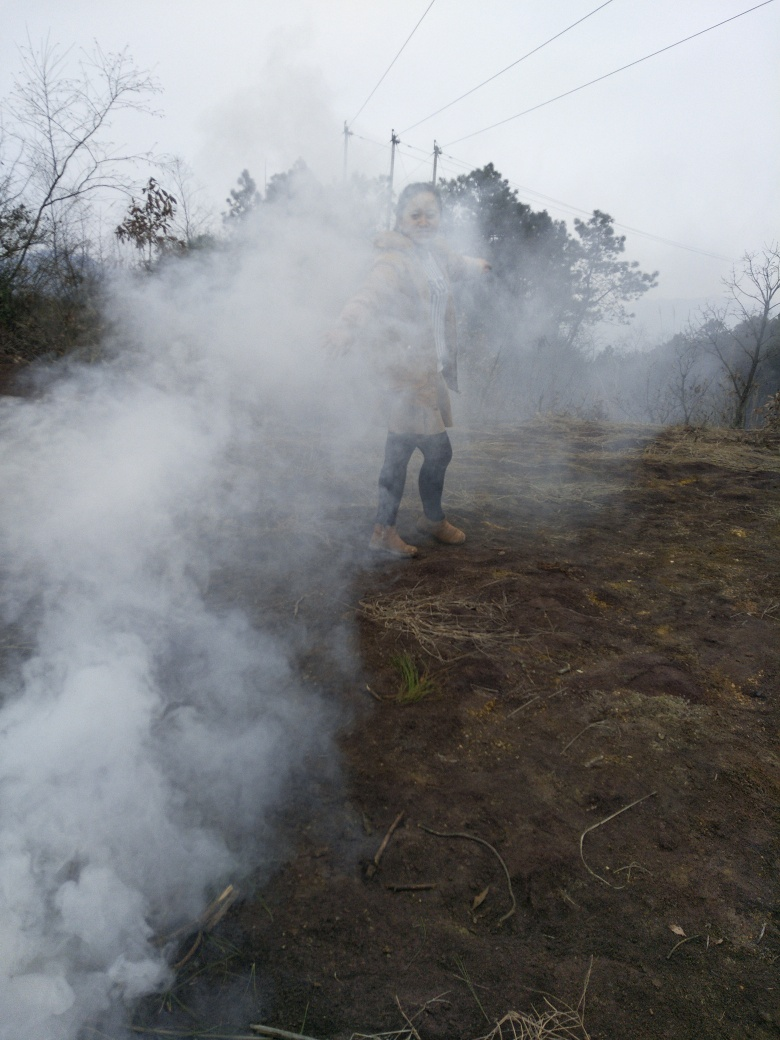What is causing the smoke in the image? Based on the image, it's not possible to determine the exact source of the smoke with certainty. However, it could be from a variety of sources such as a controlled agricultural burn, a small-scale fire for land clearing, or perhaps even a natural occurrence like a geothermal vent if in a volcanic area. The smoke appears thick and concentrated, suggesting it originates from a localized source on the ground. 